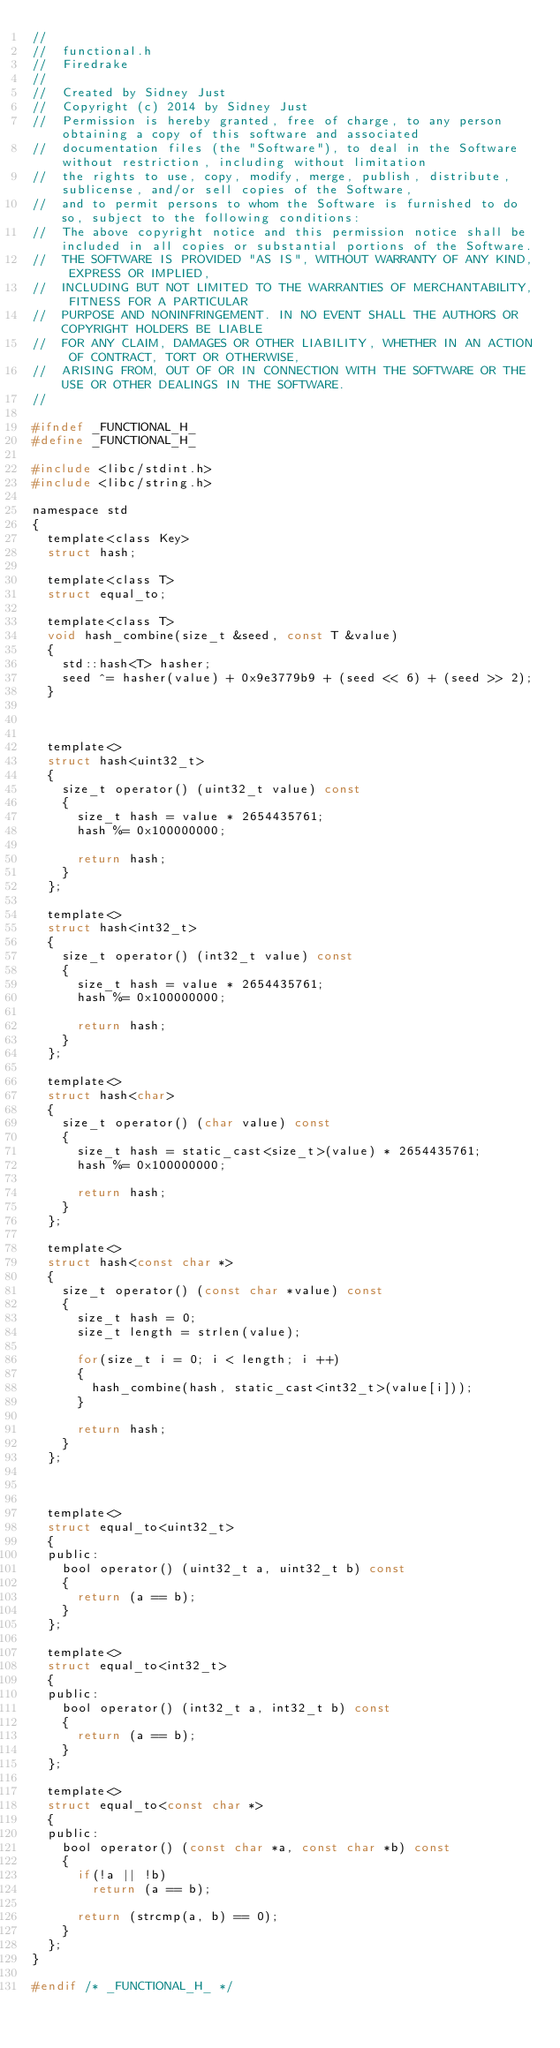Convert code to text. <code><loc_0><loc_0><loc_500><loc_500><_C_>//
//  functional.h
//  Firedrake
//
//  Created by Sidney Just
//  Copyright (c) 2014 by Sidney Just
//  Permission is hereby granted, free of charge, to any person obtaining a copy of this software and associated 
//  documentation files (the "Software"), to deal in the Software without restriction, including without limitation 
//  the rights to use, copy, modify, merge, publish, distribute, sublicense, and/or sell copies of the Software, 
//  and to permit persons to whom the Software is furnished to do so, subject to the following conditions:
//  The above copyright notice and this permission notice shall be included in all copies or substantial portions of the Software.
//  THE SOFTWARE IS PROVIDED "AS IS", WITHOUT WARRANTY OF ANY KIND, EXPRESS OR IMPLIED, 
//  INCLUDING BUT NOT LIMITED TO THE WARRANTIES OF MERCHANTABILITY, FITNESS FOR A PARTICULAR 
//  PURPOSE AND NONINFRINGEMENT. IN NO EVENT SHALL THE AUTHORS OR COPYRIGHT HOLDERS BE LIABLE 
//  FOR ANY CLAIM, DAMAGES OR OTHER LIABILITY, WHETHER IN AN ACTION OF CONTRACT, TORT OR OTHERWISE, 
//  ARISING FROM, OUT OF OR IN CONNECTION WITH THE SOFTWARE OR THE USE OR OTHER DEALINGS IN THE SOFTWARE.
//

#ifndef _FUNCTIONAL_H_
#define _FUNCTIONAL_H_

#include <libc/stdint.h>
#include <libc/string.h>

namespace std
{
	template<class Key>
	struct hash;

	template<class T>
	struct equal_to;

	template<class T>
	void hash_combine(size_t &seed, const T &value)
	{
		std::hash<T> hasher;
		seed ^= hasher(value) + 0x9e3779b9 + (seed << 6) + (seed >> 2);
	}



	template<>
	struct hash<uint32_t>
	{
		size_t operator() (uint32_t value) const
		{
			size_t hash = value * 2654435761;
			hash %= 0x100000000;

			return hash;
		}
	};

	template<>
	struct hash<int32_t>
	{
		size_t operator() (int32_t value) const
		{
			size_t hash = value * 2654435761;
			hash %= 0x100000000;

			return hash;
		}
	};

	template<>
	struct hash<char>
	{
		size_t operator() (char value) const
		{
			size_t hash = static_cast<size_t>(value) * 2654435761;
			hash %= 0x100000000;

			return hash;
		}
	};

	template<>
	struct hash<const char *>
	{
		size_t operator() (const char *value) const
		{
			size_t hash = 0;
			size_t length = strlen(value);

			for(size_t i = 0; i < length; i ++)
			{
				hash_combine(hash, static_cast<int32_t>(value[i]));
			}

			return hash;
		}
	};



	template<>
	struct equal_to<uint32_t>
	{
	public:
		bool operator() (uint32_t a, uint32_t b) const
		{
			return (a == b);
		}
	};

	template<>
	struct equal_to<int32_t>
	{
	public:
		bool operator() (int32_t a, int32_t b) const
		{
			return (a == b);
		}
	};

	template<>
	struct equal_to<const char *>
	{
	public:
		bool operator() (const char *a, const char *b) const
		{
			if(!a || !b)
				return (a == b);

			return (strcmp(a, b) == 0);
		}
	};
}

#endif /* _FUNCTIONAL_H_ */
</code> 